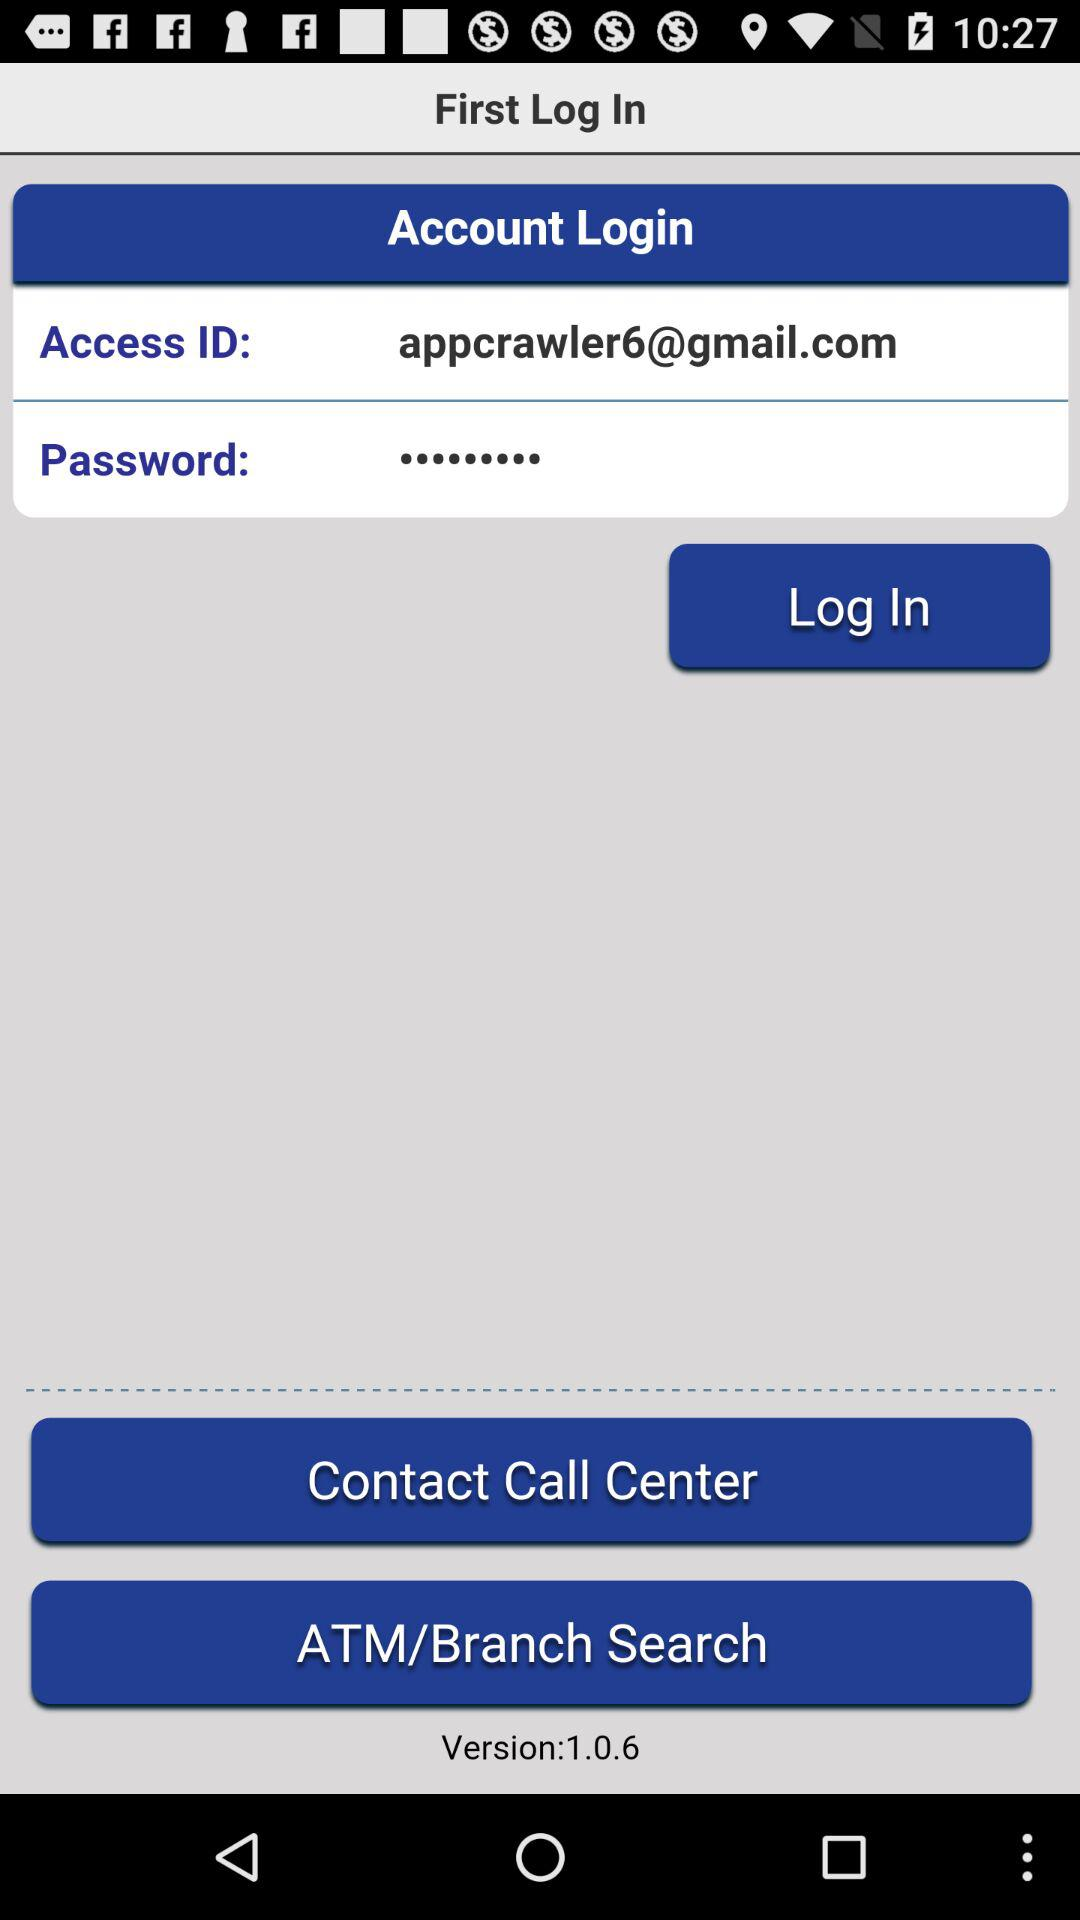What is the access ID? The access ID is appcrawler6@gmail.com. 